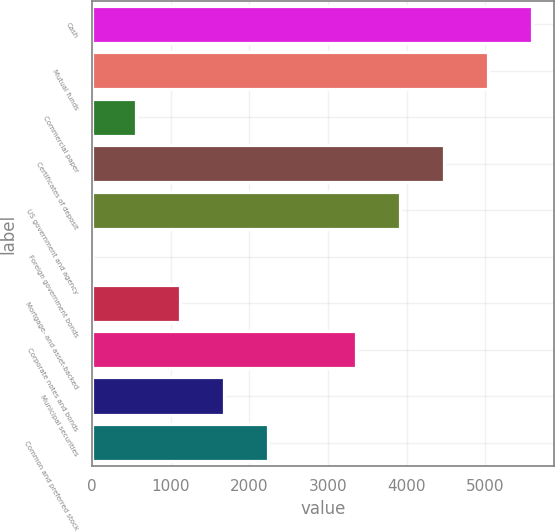Convert chart to OTSL. <chart><loc_0><loc_0><loc_500><loc_500><bar_chart><fcel>Cash<fcel>Mutual funds<fcel>Commercial paper<fcel>Certificates of deposit<fcel>US government and agency<fcel>Foreign government bonds<fcel>Mortgage- and asset-backed<fcel>Corporate notes and bonds<fcel>Municipal securities<fcel>Common and preferred stock<nl><fcel>5594.96<fcel>5035.51<fcel>559.91<fcel>4476.06<fcel>3916.61<fcel>0.46<fcel>1119.36<fcel>3357.16<fcel>1678.81<fcel>2238.26<nl></chart> 